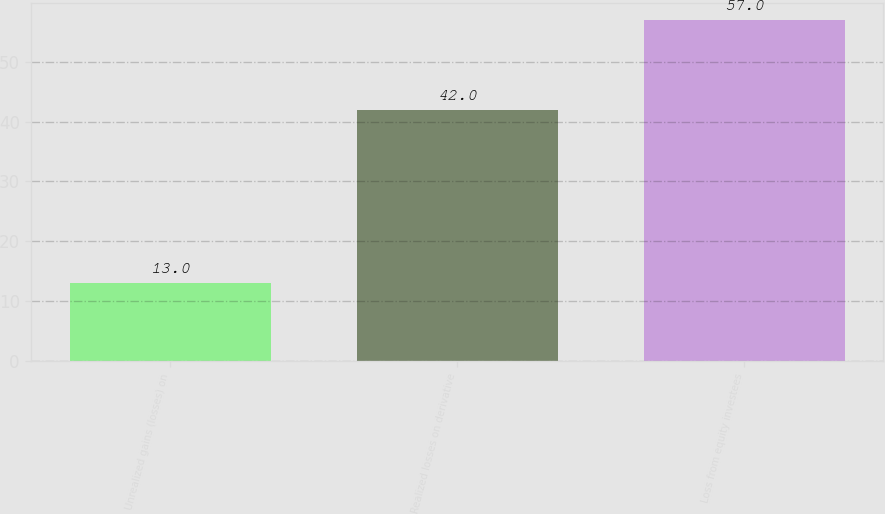<chart> <loc_0><loc_0><loc_500><loc_500><bar_chart><fcel>Unrealized gains (losses) on<fcel>Realized losses on derivative<fcel>Loss from equity investees<nl><fcel>13<fcel>42<fcel>57<nl></chart> 